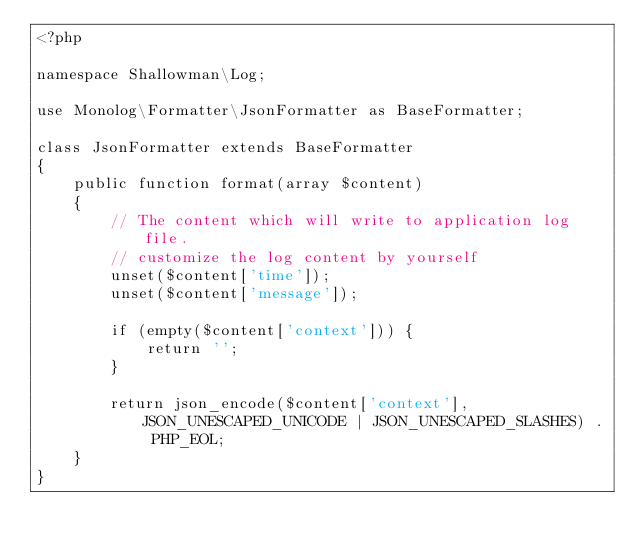Convert code to text. <code><loc_0><loc_0><loc_500><loc_500><_PHP_><?php

namespace Shallowman\Log;

use Monolog\Formatter\JsonFormatter as BaseFormatter;

class JsonFormatter extends BaseFormatter
{
    public function format(array $content)
    {
        // The content which will write to application log file.
        // customize the log content by yourself
        unset($content['time']);
        unset($content['message']);

        if (empty($content['context'])) {
            return '';
        }

        return json_encode($content['context'], JSON_UNESCAPED_UNICODE | JSON_UNESCAPED_SLASHES) . PHP_EOL;
    }
}</code> 